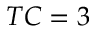Convert formula to latex. <formula><loc_0><loc_0><loc_500><loc_500>T C = 3</formula> 